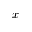Convert formula to latex. <formula><loc_0><loc_0><loc_500><loc_500>x</formula> 